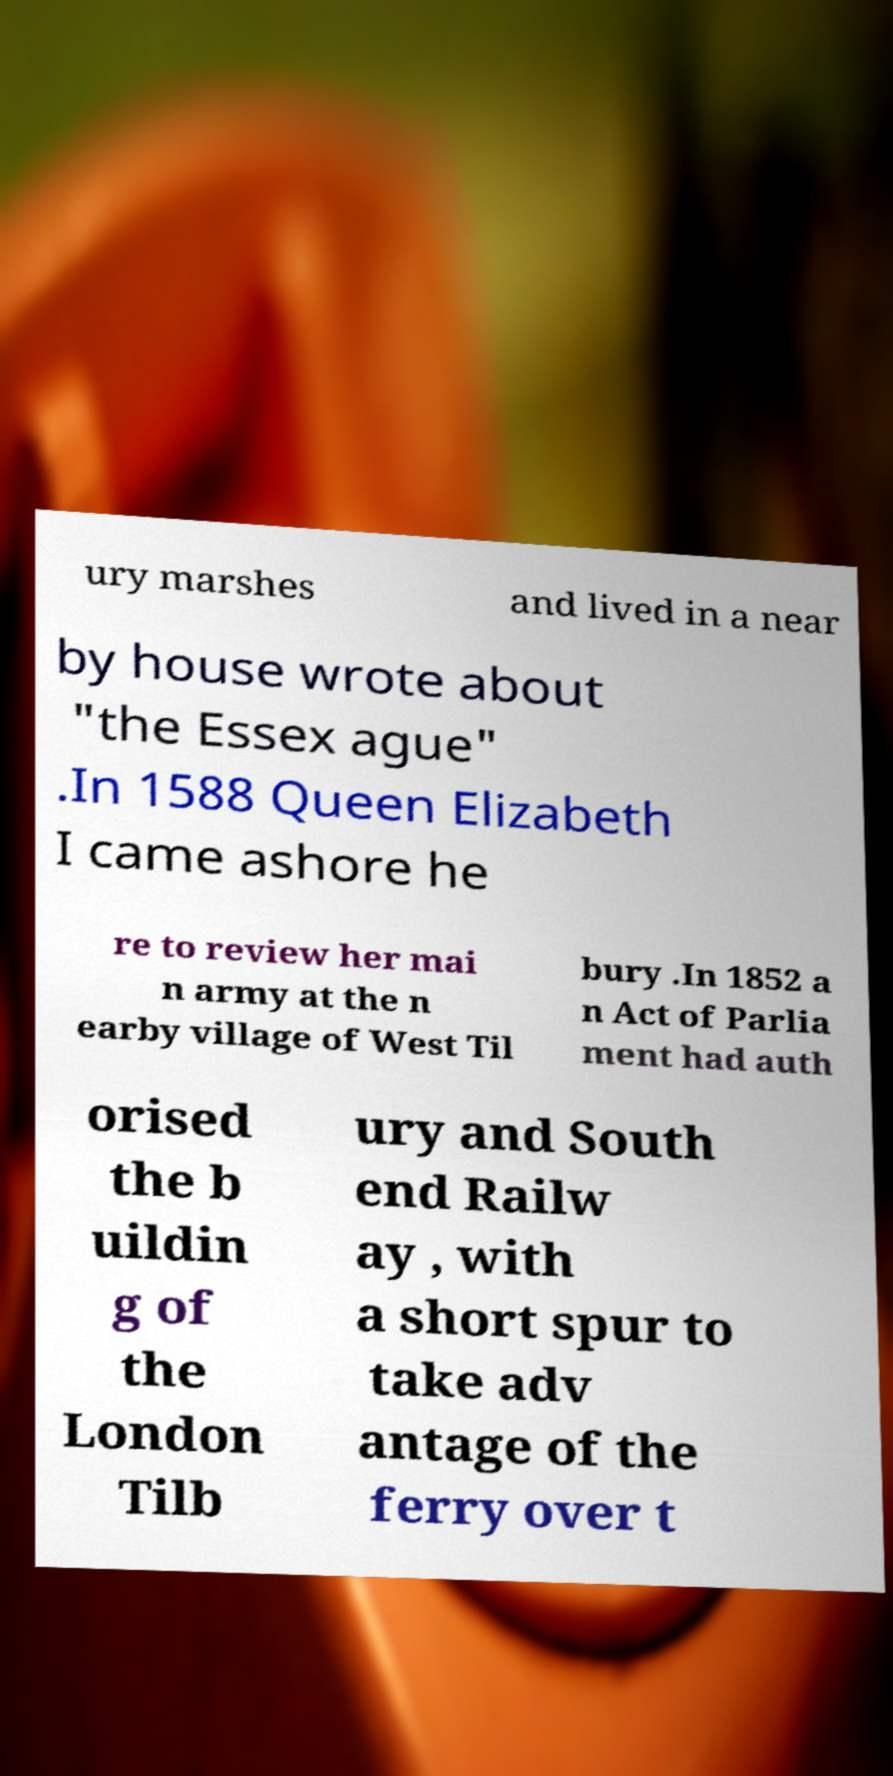Could you assist in decoding the text presented in this image and type it out clearly? ury marshes and lived in a near by house wrote about "the Essex ague" .In 1588 Queen Elizabeth I came ashore he re to review her mai n army at the n earby village of West Til bury .In 1852 a n Act of Parlia ment had auth orised the b uildin g of the London Tilb ury and South end Railw ay , with a short spur to take adv antage of the ferry over t 